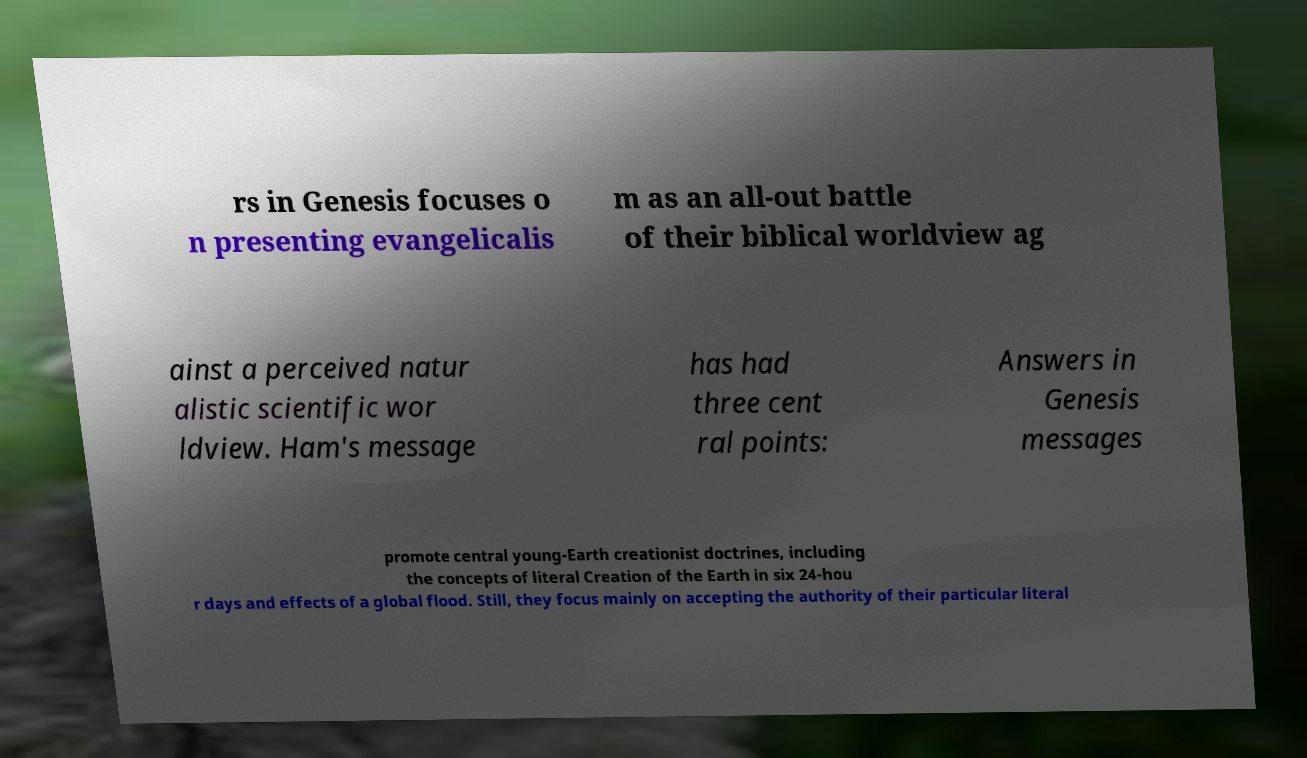Please identify and transcribe the text found in this image. rs in Genesis focuses o n presenting evangelicalis m as an all-out battle of their biblical worldview ag ainst a perceived natur alistic scientific wor ldview. Ham's message has had three cent ral points: Answers in Genesis messages promote central young-Earth creationist doctrines, including the concepts of literal Creation of the Earth in six 24-hou r days and effects of a global flood. Still, they focus mainly on accepting the authority of their particular literal 